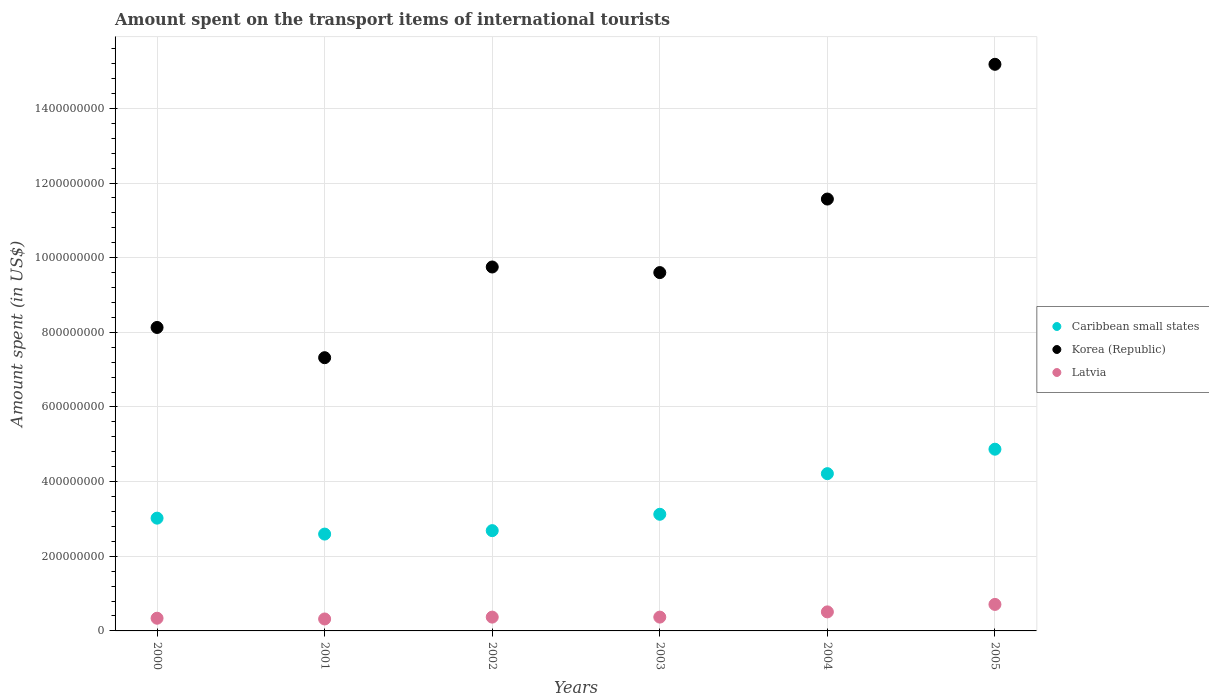Is the number of dotlines equal to the number of legend labels?
Provide a short and direct response. Yes. What is the amount spent on the transport items of international tourists in Caribbean small states in 2005?
Offer a terse response. 4.87e+08. Across all years, what is the maximum amount spent on the transport items of international tourists in Korea (Republic)?
Your response must be concise. 1.52e+09. Across all years, what is the minimum amount spent on the transport items of international tourists in Latvia?
Provide a succinct answer. 3.20e+07. What is the total amount spent on the transport items of international tourists in Caribbean small states in the graph?
Offer a terse response. 2.05e+09. What is the difference between the amount spent on the transport items of international tourists in Latvia in 2004 and that in 2005?
Provide a succinct answer. -2.00e+07. What is the difference between the amount spent on the transport items of international tourists in Latvia in 2002 and the amount spent on the transport items of international tourists in Caribbean small states in 2005?
Provide a short and direct response. -4.50e+08. What is the average amount spent on the transport items of international tourists in Caribbean small states per year?
Provide a succinct answer. 3.42e+08. In the year 2004, what is the difference between the amount spent on the transport items of international tourists in Latvia and amount spent on the transport items of international tourists in Korea (Republic)?
Provide a short and direct response. -1.11e+09. In how many years, is the amount spent on the transport items of international tourists in Caribbean small states greater than 800000000 US$?
Your answer should be compact. 0. What is the ratio of the amount spent on the transport items of international tourists in Korea (Republic) in 2003 to that in 2004?
Ensure brevity in your answer.  0.83. What is the difference between the highest and the second highest amount spent on the transport items of international tourists in Latvia?
Offer a very short reply. 2.00e+07. What is the difference between the highest and the lowest amount spent on the transport items of international tourists in Korea (Republic)?
Your answer should be very brief. 7.86e+08. In how many years, is the amount spent on the transport items of international tourists in Caribbean small states greater than the average amount spent on the transport items of international tourists in Caribbean small states taken over all years?
Provide a short and direct response. 2. Is it the case that in every year, the sum of the amount spent on the transport items of international tourists in Korea (Republic) and amount spent on the transport items of international tourists in Latvia  is greater than the amount spent on the transport items of international tourists in Caribbean small states?
Offer a terse response. Yes. Does the amount spent on the transport items of international tourists in Latvia monotonically increase over the years?
Your answer should be compact. No. What is the difference between two consecutive major ticks on the Y-axis?
Give a very brief answer. 2.00e+08. Are the values on the major ticks of Y-axis written in scientific E-notation?
Your response must be concise. No. Does the graph contain grids?
Ensure brevity in your answer.  Yes. How many legend labels are there?
Ensure brevity in your answer.  3. How are the legend labels stacked?
Provide a short and direct response. Vertical. What is the title of the graph?
Keep it short and to the point. Amount spent on the transport items of international tourists. Does "Rwanda" appear as one of the legend labels in the graph?
Offer a very short reply. No. What is the label or title of the Y-axis?
Ensure brevity in your answer.  Amount spent (in US$). What is the Amount spent (in US$) in Caribbean small states in 2000?
Offer a very short reply. 3.02e+08. What is the Amount spent (in US$) in Korea (Republic) in 2000?
Your response must be concise. 8.13e+08. What is the Amount spent (in US$) in Latvia in 2000?
Provide a succinct answer. 3.40e+07. What is the Amount spent (in US$) in Caribbean small states in 2001?
Offer a terse response. 2.59e+08. What is the Amount spent (in US$) of Korea (Republic) in 2001?
Give a very brief answer. 7.32e+08. What is the Amount spent (in US$) of Latvia in 2001?
Offer a terse response. 3.20e+07. What is the Amount spent (in US$) of Caribbean small states in 2002?
Offer a very short reply. 2.69e+08. What is the Amount spent (in US$) in Korea (Republic) in 2002?
Ensure brevity in your answer.  9.75e+08. What is the Amount spent (in US$) in Latvia in 2002?
Your answer should be very brief. 3.70e+07. What is the Amount spent (in US$) of Caribbean small states in 2003?
Make the answer very short. 3.12e+08. What is the Amount spent (in US$) in Korea (Republic) in 2003?
Keep it short and to the point. 9.60e+08. What is the Amount spent (in US$) in Latvia in 2003?
Your response must be concise. 3.70e+07. What is the Amount spent (in US$) of Caribbean small states in 2004?
Provide a short and direct response. 4.21e+08. What is the Amount spent (in US$) of Korea (Republic) in 2004?
Make the answer very short. 1.16e+09. What is the Amount spent (in US$) in Latvia in 2004?
Offer a terse response. 5.10e+07. What is the Amount spent (in US$) in Caribbean small states in 2005?
Your response must be concise. 4.87e+08. What is the Amount spent (in US$) in Korea (Republic) in 2005?
Offer a terse response. 1.52e+09. What is the Amount spent (in US$) in Latvia in 2005?
Your answer should be compact. 7.10e+07. Across all years, what is the maximum Amount spent (in US$) of Caribbean small states?
Make the answer very short. 4.87e+08. Across all years, what is the maximum Amount spent (in US$) of Korea (Republic)?
Your answer should be very brief. 1.52e+09. Across all years, what is the maximum Amount spent (in US$) of Latvia?
Provide a short and direct response. 7.10e+07. Across all years, what is the minimum Amount spent (in US$) in Caribbean small states?
Your answer should be compact. 2.59e+08. Across all years, what is the minimum Amount spent (in US$) of Korea (Republic)?
Give a very brief answer. 7.32e+08. Across all years, what is the minimum Amount spent (in US$) in Latvia?
Your answer should be very brief. 3.20e+07. What is the total Amount spent (in US$) of Caribbean small states in the graph?
Offer a very short reply. 2.05e+09. What is the total Amount spent (in US$) in Korea (Republic) in the graph?
Ensure brevity in your answer.  6.16e+09. What is the total Amount spent (in US$) in Latvia in the graph?
Offer a terse response. 2.62e+08. What is the difference between the Amount spent (in US$) of Caribbean small states in 2000 and that in 2001?
Provide a short and direct response. 4.27e+07. What is the difference between the Amount spent (in US$) of Korea (Republic) in 2000 and that in 2001?
Keep it short and to the point. 8.10e+07. What is the difference between the Amount spent (in US$) in Latvia in 2000 and that in 2001?
Offer a terse response. 2.00e+06. What is the difference between the Amount spent (in US$) in Caribbean small states in 2000 and that in 2002?
Offer a very short reply. 3.34e+07. What is the difference between the Amount spent (in US$) in Korea (Republic) in 2000 and that in 2002?
Your answer should be very brief. -1.62e+08. What is the difference between the Amount spent (in US$) of Caribbean small states in 2000 and that in 2003?
Make the answer very short. -1.04e+07. What is the difference between the Amount spent (in US$) of Korea (Republic) in 2000 and that in 2003?
Offer a very short reply. -1.47e+08. What is the difference between the Amount spent (in US$) in Latvia in 2000 and that in 2003?
Make the answer very short. -3.00e+06. What is the difference between the Amount spent (in US$) in Caribbean small states in 2000 and that in 2004?
Ensure brevity in your answer.  -1.19e+08. What is the difference between the Amount spent (in US$) of Korea (Republic) in 2000 and that in 2004?
Offer a terse response. -3.44e+08. What is the difference between the Amount spent (in US$) of Latvia in 2000 and that in 2004?
Offer a terse response. -1.70e+07. What is the difference between the Amount spent (in US$) in Caribbean small states in 2000 and that in 2005?
Your answer should be compact. -1.85e+08. What is the difference between the Amount spent (in US$) of Korea (Republic) in 2000 and that in 2005?
Offer a terse response. -7.05e+08. What is the difference between the Amount spent (in US$) in Latvia in 2000 and that in 2005?
Provide a succinct answer. -3.70e+07. What is the difference between the Amount spent (in US$) of Caribbean small states in 2001 and that in 2002?
Your answer should be very brief. -9.22e+06. What is the difference between the Amount spent (in US$) of Korea (Republic) in 2001 and that in 2002?
Give a very brief answer. -2.43e+08. What is the difference between the Amount spent (in US$) in Latvia in 2001 and that in 2002?
Keep it short and to the point. -5.00e+06. What is the difference between the Amount spent (in US$) in Caribbean small states in 2001 and that in 2003?
Your response must be concise. -5.30e+07. What is the difference between the Amount spent (in US$) in Korea (Republic) in 2001 and that in 2003?
Offer a terse response. -2.28e+08. What is the difference between the Amount spent (in US$) in Latvia in 2001 and that in 2003?
Your answer should be compact. -5.00e+06. What is the difference between the Amount spent (in US$) in Caribbean small states in 2001 and that in 2004?
Ensure brevity in your answer.  -1.62e+08. What is the difference between the Amount spent (in US$) in Korea (Republic) in 2001 and that in 2004?
Ensure brevity in your answer.  -4.25e+08. What is the difference between the Amount spent (in US$) in Latvia in 2001 and that in 2004?
Offer a very short reply. -1.90e+07. What is the difference between the Amount spent (in US$) in Caribbean small states in 2001 and that in 2005?
Keep it short and to the point. -2.27e+08. What is the difference between the Amount spent (in US$) of Korea (Republic) in 2001 and that in 2005?
Give a very brief answer. -7.86e+08. What is the difference between the Amount spent (in US$) of Latvia in 2001 and that in 2005?
Give a very brief answer. -3.90e+07. What is the difference between the Amount spent (in US$) in Caribbean small states in 2002 and that in 2003?
Make the answer very short. -4.38e+07. What is the difference between the Amount spent (in US$) in Korea (Republic) in 2002 and that in 2003?
Provide a succinct answer. 1.50e+07. What is the difference between the Amount spent (in US$) in Caribbean small states in 2002 and that in 2004?
Provide a succinct answer. -1.53e+08. What is the difference between the Amount spent (in US$) of Korea (Republic) in 2002 and that in 2004?
Offer a very short reply. -1.82e+08. What is the difference between the Amount spent (in US$) of Latvia in 2002 and that in 2004?
Your answer should be very brief. -1.40e+07. What is the difference between the Amount spent (in US$) in Caribbean small states in 2002 and that in 2005?
Give a very brief answer. -2.18e+08. What is the difference between the Amount spent (in US$) in Korea (Republic) in 2002 and that in 2005?
Provide a succinct answer. -5.43e+08. What is the difference between the Amount spent (in US$) of Latvia in 2002 and that in 2005?
Keep it short and to the point. -3.40e+07. What is the difference between the Amount spent (in US$) in Caribbean small states in 2003 and that in 2004?
Your response must be concise. -1.09e+08. What is the difference between the Amount spent (in US$) of Korea (Republic) in 2003 and that in 2004?
Make the answer very short. -1.97e+08. What is the difference between the Amount spent (in US$) of Latvia in 2003 and that in 2004?
Provide a short and direct response. -1.40e+07. What is the difference between the Amount spent (in US$) of Caribbean small states in 2003 and that in 2005?
Give a very brief answer. -1.74e+08. What is the difference between the Amount spent (in US$) in Korea (Republic) in 2003 and that in 2005?
Your answer should be very brief. -5.58e+08. What is the difference between the Amount spent (in US$) of Latvia in 2003 and that in 2005?
Offer a terse response. -3.40e+07. What is the difference between the Amount spent (in US$) in Caribbean small states in 2004 and that in 2005?
Keep it short and to the point. -6.55e+07. What is the difference between the Amount spent (in US$) of Korea (Republic) in 2004 and that in 2005?
Give a very brief answer. -3.61e+08. What is the difference between the Amount spent (in US$) in Latvia in 2004 and that in 2005?
Offer a terse response. -2.00e+07. What is the difference between the Amount spent (in US$) of Caribbean small states in 2000 and the Amount spent (in US$) of Korea (Republic) in 2001?
Offer a terse response. -4.30e+08. What is the difference between the Amount spent (in US$) in Caribbean small states in 2000 and the Amount spent (in US$) in Latvia in 2001?
Offer a terse response. 2.70e+08. What is the difference between the Amount spent (in US$) of Korea (Republic) in 2000 and the Amount spent (in US$) of Latvia in 2001?
Your answer should be very brief. 7.81e+08. What is the difference between the Amount spent (in US$) of Caribbean small states in 2000 and the Amount spent (in US$) of Korea (Republic) in 2002?
Your answer should be very brief. -6.73e+08. What is the difference between the Amount spent (in US$) of Caribbean small states in 2000 and the Amount spent (in US$) of Latvia in 2002?
Provide a short and direct response. 2.65e+08. What is the difference between the Amount spent (in US$) of Korea (Republic) in 2000 and the Amount spent (in US$) of Latvia in 2002?
Give a very brief answer. 7.76e+08. What is the difference between the Amount spent (in US$) of Caribbean small states in 2000 and the Amount spent (in US$) of Korea (Republic) in 2003?
Provide a succinct answer. -6.58e+08. What is the difference between the Amount spent (in US$) of Caribbean small states in 2000 and the Amount spent (in US$) of Latvia in 2003?
Your answer should be very brief. 2.65e+08. What is the difference between the Amount spent (in US$) in Korea (Republic) in 2000 and the Amount spent (in US$) in Latvia in 2003?
Offer a terse response. 7.76e+08. What is the difference between the Amount spent (in US$) of Caribbean small states in 2000 and the Amount spent (in US$) of Korea (Republic) in 2004?
Provide a short and direct response. -8.55e+08. What is the difference between the Amount spent (in US$) of Caribbean small states in 2000 and the Amount spent (in US$) of Latvia in 2004?
Ensure brevity in your answer.  2.51e+08. What is the difference between the Amount spent (in US$) in Korea (Republic) in 2000 and the Amount spent (in US$) in Latvia in 2004?
Offer a very short reply. 7.62e+08. What is the difference between the Amount spent (in US$) of Caribbean small states in 2000 and the Amount spent (in US$) of Korea (Republic) in 2005?
Your answer should be very brief. -1.22e+09. What is the difference between the Amount spent (in US$) of Caribbean small states in 2000 and the Amount spent (in US$) of Latvia in 2005?
Make the answer very short. 2.31e+08. What is the difference between the Amount spent (in US$) in Korea (Republic) in 2000 and the Amount spent (in US$) in Latvia in 2005?
Offer a terse response. 7.42e+08. What is the difference between the Amount spent (in US$) of Caribbean small states in 2001 and the Amount spent (in US$) of Korea (Republic) in 2002?
Offer a terse response. -7.16e+08. What is the difference between the Amount spent (in US$) in Caribbean small states in 2001 and the Amount spent (in US$) in Latvia in 2002?
Offer a terse response. 2.22e+08. What is the difference between the Amount spent (in US$) of Korea (Republic) in 2001 and the Amount spent (in US$) of Latvia in 2002?
Keep it short and to the point. 6.95e+08. What is the difference between the Amount spent (in US$) of Caribbean small states in 2001 and the Amount spent (in US$) of Korea (Republic) in 2003?
Your answer should be very brief. -7.01e+08. What is the difference between the Amount spent (in US$) of Caribbean small states in 2001 and the Amount spent (in US$) of Latvia in 2003?
Provide a succinct answer. 2.22e+08. What is the difference between the Amount spent (in US$) of Korea (Republic) in 2001 and the Amount spent (in US$) of Latvia in 2003?
Provide a succinct answer. 6.95e+08. What is the difference between the Amount spent (in US$) in Caribbean small states in 2001 and the Amount spent (in US$) in Korea (Republic) in 2004?
Give a very brief answer. -8.98e+08. What is the difference between the Amount spent (in US$) of Caribbean small states in 2001 and the Amount spent (in US$) of Latvia in 2004?
Your response must be concise. 2.08e+08. What is the difference between the Amount spent (in US$) in Korea (Republic) in 2001 and the Amount spent (in US$) in Latvia in 2004?
Make the answer very short. 6.81e+08. What is the difference between the Amount spent (in US$) in Caribbean small states in 2001 and the Amount spent (in US$) in Korea (Republic) in 2005?
Offer a terse response. -1.26e+09. What is the difference between the Amount spent (in US$) of Caribbean small states in 2001 and the Amount spent (in US$) of Latvia in 2005?
Keep it short and to the point. 1.88e+08. What is the difference between the Amount spent (in US$) in Korea (Republic) in 2001 and the Amount spent (in US$) in Latvia in 2005?
Offer a very short reply. 6.61e+08. What is the difference between the Amount spent (in US$) in Caribbean small states in 2002 and the Amount spent (in US$) in Korea (Republic) in 2003?
Offer a terse response. -6.91e+08. What is the difference between the Amount spent (in US$) of Caribbean small states in 2002 and the Amount spent (in US$) of Latvia in 2003?
Keep it short and to the point. 2.32e+08. What is the difference between the Amount spent (in US$) in Korea (Republic) in 2002 and the Amount spent (in US$) in Latvia in 2003?
Provide a short and direct response. 9.38e+08. What is the difference between the Amount spent (in US$) of Caribbean small states in 2002 and the Amount spent (in US$) of Korea (Republic) in 2004?
Offer a terse response. -8.88e+08. What is the difference between the Amount spent (in US$) of Caribbean small states in 2002 and the Amount spent (in US$) of Latvia in 2004?
Ensure brevity in your answer.  2.18e+08. What is the difference between the Amount spent (in US$) in Korea (Republic) in 2002 and the Amount spent (in US$) in Latvia in 2004?
Offer a very short reply. 9.24e+08. What is the difference between the Amount spent (in US$) in Caribbean small states in 2002 and the Amount spent (in US$) in Korea (Republic) in 2005?
Provide a short and direct response. -1.25e+09. What is the difference between the Amount spent (in US$) of Caribbean small states in 2002 and the Amount spent (in US$) of Latvia in 2005?
Offer a very short reply. 1.98e+08. What is the difference between the Amount spent (in US$) in Korea (Republic) in 2002 and the Amount spent (in US$) in Latvia in 2005?
Offer a very short reply. 9.04e+08. What is the difference between the Amount spent (in US$) in Caribbean small states in 2003 and the Amount spent (in US$) in Korea (Republic) in 2004?
Your response must be concise. -8.45e+08. What is the difference between the Amount spent (in US$) in Caribbean small states in 2003 and the Amount spent (in US$) in Latvia in 2004?
Provide a short and direct response. 2.61e+08. What is the difference between the Amount spent (in US$) in Korea (Republic) in 2003 and the Amount spent (in US$) in Latvia in 2004?
Your answer should be compact. 9.09e+08. What is the difference between the Amount spent (in US$) in Caribbean small states in 2003 and the Amount spent (in US$) in Korea (Republic) in 2005?
Make the answer very short. -1.21e+09. What is the difference between the Amount spent (in US$) of Caribbean small states in 2003 and the Amount spent (in US$) of Latvia in 2005?
Keep it short and to the point. 2.41e+08. What is the difference between the Amount spent (in US$) in Korea (Republic) in 2003 and the Amount spent (in US$) in Latvia in 2005?
Make the answer very short. 8.89e+08. What is the difference between the Amount spent (in US$) in Caribbean small states in 2004 and the Amount spent (in US$) in Korea (Republic) in 2005?
Your answer should be compact. -1.10e+09. What is the difference between the Amount spent (in US$) of Caribbean small states in 2004 and the Amount spent (in US$) of Latvia in 2005?
Ensure brevity in your answer.  3.50e+08. What is the difference between the Amount spent (in US$) in Korea (Republic) in 2004 and the Amount spent (in US$) in Latvia in 2005?
Keep it short and to the point. 1.09e+09. What is the average Amount spent (in US$) of Caribbean small states per year?
Offer a very short reply. 3.42e+08. What is the average Amount spent (in US$) in Korea (Republic) per year?
Make the answer very short. 1.03e+09. What is the average Amount spent (in US$) in Latvia per year?
Give a very brief answer. 4.37e+07. In the year 2000, what is the difference between the Amount spent (in US$) of Caribbean small states and Amount spent (in US$) of Korea (Republic)?
Your response must be concise. -5.11e+08. In the year 2000, what is the difference between the Amount spent (in US$) in Caribbean small states and Amount spent (in US$) in Latvia?
Ensure brevity in your answer.  2.68e+08. In the year 2000, what is the difference between the Amount spent (in US$) of Korea (Republic) and Amount spent (in US$) of Latvia?
Your answer should be compact. 7.79e+08. In the year 2001, what is the difference between the Amount spent (in US$) in Caribbean small states and Amount spent (in US$) in Korea (Republic)?
Ensure brevity in your answer.  -4.73e+08. In the year 2001, what is the difference between the Amount spent (in US$) of Caribbean small states and Amount spent (in US$) of Latvia?
Make the answer very short. 2.27e+08. In the year 2001, what is the difference between the Amount spent (in US$) in Korea (Republic) and Amount spent (in US$) in Latvia?
Your answer should be very brief. 7.00e+08. In the year 2002, what is the difference between the Amount spent (in US$) in Caribbean small states and Amount spent (in US$) in Korea (Republic)?
Provide a succinct answer. -7.06e+08. In the year 2002, what is the difference between the Amount spent (in US$) in Caribbean small states and Amount spent (in US$) in Latvia?
Offer a terse response. 2.32e+08. In the year 2002, what is the difference between the Amount spent (in US$) in Korea (Republic) and Amount spent (in US$) in Latvia?
Ensure brevity in your answer.  9.38e+08. In the year 2003, what is the difference between the Amount spent (in US$) of Caribbean small states and Amount spent (in US$) of Korea (Republic)?
Provide a short and direct response. -6.48e+08. In the year 2003, what is the difference between the Amount spent (in US$) of Caribbean small states and Amount spent (in US$) of Latvia?
Give a very brief answer. 2.75e+08. In the year 2003, what is the difference between the Amount spent (in US$) in Korea (Republic) and Amount spent (in US$) in Latvia?
Give a very brief answer. 9.23e+08. In the year 2004, what is the difference between the Amount spent (in US$) of Caribbean small states and Amount spent (in US$) of Korea (Republic)?
Give a very brief answer. -7.36e+08. In the year 2004, what is the difference between the Amount spent (in US$) in Caribbean small states and Amount spent (in US$) in Latvia?
Your response must be concise. 3.70e+08. In the year 2004, what is the difference between the Amount spent (in US$) of Korea (Republic) and Amount spent (in US$) of Latvia?
Make the answer very short. 1.11e+09. In the year 2005, what is the difference between the Amount spent (in US$) in Caribbean small states and Amount spent (in US$) in Korea (Republic)?
Keep it short and to the point. -1.03e+09. In the year 2005, what is the difference between the Amount spent (in US$) in Caribbean small states and Amount spent (in US$) in Latvia?
Offer a very short reply. 4.16e+08. In the year 2005, what is the difference between the Amount spent (in US$) in Korea (Republic) and Amount spent (in US$) in Latvia?
Ensure brevity in your answer.  1.45e+09. What is the ratio of the Amount spent (in US$) of Caribbean small states in 2000 to that in 2001?
Give a very brief answer. 1.16. What is the ratio of the Amount spent (in US$) in Korea (Republic) in 2000 to that in 2001?
Ensure brevity in your answer.  1.11. What is the ratio of the Amount spent (in US$) of Latvia in 2000 to that in 2001?
Provide a succinct answer. 1.06. What is the ratio of the Amount spent (in US$) in Caribbean small states in 2000 to that in 2002?
Keep it short and to the point. 1.12. What is the ratio of the Amount spent (in US$) of Korea (Republic) in 2000 to that in 2002?
Make the answer very short. 0.83. What is the ratio of the Amount spent (in US$) in Latvia in 2000 to that in 2002?
Provide a succinct answer. 0.92. What is the ratio of the Amount spent (in US$) in Caribbean small states in 2000 to that in 2003?
Offer a terse response. 0.97. What is the ratio of the Amount spent (in US$) in Korea (Republic) in 2000 to that in 2003?
Offer a very short reply. 0.85. What is the ratio of the Amount spent (in US$) of Latvia in 2000 to that in 2003?
Provide a succinct answer. 0.92. What is the ratio of the Amount spent (in US$) of Caribbean small states in 2000 to that in 2004?
Your response must be concise. 0.72. What is the ratio of the Amount spent (in US$) of Korea (Republic) in 2000 to that in 2004?
Provide a short and direct response. 0.7. What is the ratio of the Amount spent (in US$) in Caribbean small states in 2000 to that in 2005?
Your answer should be compact. 0.62. What is the ratio of the Amount spent (in US$) in Korea (Republic) in 2000 to that in 2005?
Keep it short and to the point. 0.54. What is the ratio of the Amount spent (in US$) in Latvia in 2000 to that in 2005?
Offer a terse response. 0.48. What is the ratio of the Amount spent (in US$) of Caribbean small states in 2001 to that in 2002?
Your answer should be compact. 0.97. What is the ratio of the Amount spent (in US$) in Korea (Republic) in 2001 to that in 2002?
Provide a short and direct response. 0.75. What is the ratio of the Amount spent (in US$) in Latvia in 2001 to that in 2002?
Your answer should be compact. 0.86. What is the ratio of the Amount spent (in US$) in Caribbean small states in 2001 to that in 2003?
Offer a very short reply. 0.83. What is the ratio of the Amount spent (in US$) in Korea (Republic) in 2001 to that in 2003?
Offer a terse response. 0.76. What is the ratio of the Amount spent (in US$) of Latvia in 2001 to that in 2003?
Make the answer very short. 0.86. What is the ratio of the Amount spent (in US$) in Caribbean small states in 2001 to that in 2004?
Give a very brief answer. 0.62. What is the ratio of the Amount spent (in US$) of Korea (Republic) in 2001 to that in 2004?
Your answer should be very brief. 0.63. What is the ratio of the Amount spent (in US$) of Latvia in 2001 to that in 2004?
Ensure brevity in your answer.  0.63. What is the ratio of the Amount spent (in US$) of Caribbean small states in 2001 to that in 2005?
Provide a succinct answer. 0.53. What is the ratio of the Amount spent (in US$) of Korea (Republic) in 2001 to that in 2005?
Ensure brevity in your answer.  0.48. What is the ratio of the Amount spent (in US$) in Latvia in 2001 to that in 2005?
Make the answer very short. 0.45. What is the ratio of the Amount spent (in US$) in Caribbean small states in 2002 to that in 2003?
Make the answer very short. 0.86. What is the ratio of the Amount spent (in US$) in Korea (Republic) in 2002 to that in 2003?
Make the answer very short. 1.02. What is the ratio of the Amount spent (in US$) in Caribbean small states in 2002 to that in 2004?
Provide a succinct answer. 0.64. What is the ratio of the Amount spent (in US$) of Korea (Republic) in 2002 to that in 2004?
Provide a short and direct response. 0.84. What is the ratio of the Amount spent (in US$) in Latvia in 2002 to that in 2004?
Give a very brief answer. 0.73. What is the ratio of the Amount spent (in US$) in Caribbean small states in 2002 to that in 2005?
Keep it short and to the point. 0.55. What is the ratio of the Amount spent (in US$) in Korea (Republic) in 2002 to that in 2005?
Provide a succinct answer. 0.64. What is the ratio of the Amount spent (in US$) of Latvia in 2002 to that in 2005?
Your answer should be very brief. 0.52. What is the ratio of the Amount spent (in US$) of Caribbean small states in 2003 to that in 2004?
Offer a terse response. 0.74. What is the ratio of the Amount spent (in US$) of Korea (Republic) in 2003 to that in 2004?
Your response must be concise. 0.83. What is the ratio of the Amount spent (in US$) of Latvia in 2003 to that in 2004?
Keep it short and to the point. 0.73. What is the ratio of the Amount spent (in US$) of Caribbean small states in 2003 to that in 2005?
Your answer should be very brief. 0.64. What is the ratio of the Amount spent (in US$) of Korea (Republic) in 2003 to that in 2005?
Ensure brevity in your answer.  0.63. What is the ratio of the Amount spent (in US$) of Latvia in 2003 to that in 2005?
Make the answer very short. 0.52. What is the ratio of the Amount spent (in US$) in Caribbean small states in 2004 to that in 2005?
Your response must be concise. 0.87. What is the ratio of the Amount spent (in US$) in Korea (Republic) in 2004 to that in 2005?
Your answer should be very brief. 0.76. What is the ratio of the Amount spent (in US$) of Latvia in 2004 to that in 2005?
Keep it short and to the point. 0.72. What is the difference between the highest and the second highest Amount spent (in US$) in Caribbean small states?
Keep it short and to the point. 6.55e+07. What is the difference between the highest and the second highest Amount spent (in US$) of Korea (Republic)?
Ensure brevity in your answer.  3.61e+08. What is the difference between the highest and the lowest Amount spent (in US$) of Caribbean small states?
Keep it short and to the point. 2.27e+08. What is the difference between the highest and the lowest Amount spent (in US$) in Korea (Republic)?
Make the answer very short. 7.86e+08. What is the difference between the highest and the lowest Amount spent (in US$) in Latvia?
Your answer should be compact. 3.90e+07. 